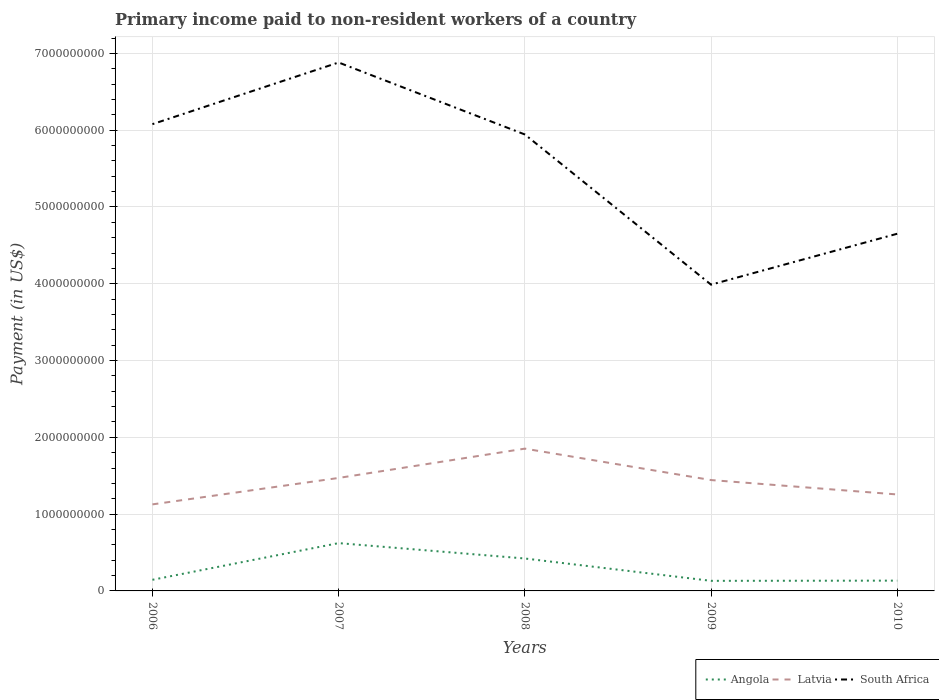How many different coloured lines are there?
Keep it short and to the point. 3. Does the line corresponding to Latvia intersect with the line corresponding to Angola?
Provide a short and direct response. No. Is the number of lines equal to the number of legend labels?
Ensure brevity in your answer.  Yes. Across all years, what is the maximum amount paid to workers in Latvia?
Make the answer very short. 1.13e+09. In which year was the amount paid to workers in Latvia maximum?
Give a very brief answer. 2006. What is the total amount paid to workers in Angola in the graph?
Make the answer very short. -4.78e+08. What is the difference between the highest and the second highest amount paid to workers in South Africa?
Keep it short and to the point. 2.89e+09. What is the difference between the highest and the lowest amount paid to workers in South Africa?
Make the answer very short. 3. Is the amount paid to workers in Angola strictly greater than the amount paid to workers in Latvia over the years?
Offer a terse response. Yes. How many lines are there?
Make the answer very short. 3. How many years are there in the graph?
Provide a succinct answer. 5. What is the difference between two consecutive major ticks on the Y-axis?
Ensure brevity in your answer.  1.00e+09. Does the graph contain grids?
Make the answer very short. Yes. Where does the legend appear in the graph?
Make the answer very short. Bottom right. What is the title of the graph?
Give a very brief answer. Primary income paid to non-resident workers of a country. What is the label or title of the Y-axis?
Make the answer very short. Payment (in US$). What is the Payment (in US$) in Angola in 2006?
Provide a succinct answer. 1.45e+08. What is the Payment (in US$) of Latvia in 2006?
Offer a terse response. 1.13e+09. What is the Payment (in US$) of South Africa in 2006?
Give a very brief answer. 6.08e+09. What is the Payment (in US$) in Angola in 2007?
Offer a terse response. 6.23e+08. What is the Payment (in US$) of Latvia in 2007?
Keep it short and to the point. 1.47e+09. What is the Payment (in US$) in South Africa in 2007?
Give a very brief answer. 6.88e+09. What is the Payment (in US$) of Angola in 2008?
Provide a succinct answer. 4.22e+08. What is the Payment (in US$) of Latvia in 2008?
Keep it short and to the point. 1.85e+09. What is the Payment (in US$) of South Africa in 2008?
Offer a very short reply. 5.94e+09. What is the Payment (in US$) in Angola in 2009?
Keep it short and to the point. 1.31e+08. What is the Payment (in US$) of Latvia in 2009?
Make the answer very short. 1.44e+09. What is the Payment (in US$) in South Africa in 2009?
Your answer should be very brief. 3.99e+09. What is the Payment (in US$) in Angola in 2010?
Provide a short and direct response. 1.34e+08. What is the Payment (in US$) in Latvia in 2010?
Give a very brief answer. 1.26e+09. What is the Payment (in US$) in South Africa in 2010?
Your answer should be compact. 4.65e+09. Across all years, what is the maximum Payment (in US$) of Angola?
Provide a succinct answer. 6.23e+08. Across all years, what is the maximum Payment (in US$) in Latvia?
Provide a succinct answer. 1.85e+09. Across all years, what is the maximum Payment (in US$) in South Africa?
Provide a succinct answer. 6.88e+09. Across all years, what is the minimum Payment (in US$) in Angola?
Keep it short and to the point. 1.31e+08. Across all years, what is the minimum Payment (in US$) of Latvia?
Offer a very short reply. 1.13e+09. Across all years, what is the minimum Payment (in US$) of South Africa?
Your answer should be compact. 3.99e+09. What is the total Payment (in US$) of Angola in the graph?
Keep it short and to the point. 1.46e+09. What is the total Payment (in US$) in Latvia in the graph?
Ensure brevity in your answer.  7.15e+09. What is the total Payment (in US$) of South Africa in the graph?
Offer a very short reply. 2.75e+1. What is the difference between the Payment (in US$) in Angola in 2006 and that in 2007?
Your answer should be very brief. -4.78e+08. What is the difference between the Payment (in US$) of Latvia in 2006 and that in 2007?
Offer a terse response. -3.44e+08. What is the difference between the Payment (in US$) of South Africa in 2006 and that in 2007?
Make the answer very short. -8.03e+08. What is the difference between the Payment (in US$) in Angola in 2006 and that in 2008?
Ensure brevity in your answer.  -2.77e+08. What is the difference between the Payment (in US$) in Latvia in 2006 and that in 2008?
Offer a terse response. -7.26e+08. What is the difference between the Payment (in US$) of South Africa in 2006 and that in 2008?
Make the answer very short. 1.34e+08. What is the difference between the Payment (in US$) in Angola in 2006 and that in 2009?
Provide a succinct answer. 1.37e+07. What is the difference between the Payment (in US$) in Latvia in 2006 and that in 2009?
Offer a terse response. -3.17e+08. What is the difference between the Payment (in US$) in South Africa in 2006 and that in 2009?
Offer a very short reply. 2.09e+09. What is the difference between the Payment (in US$) in Angola in 2006 and that in 2010?
Your response must be concise. 1.10e+07. What is the difference between the Payment (in US$) in Latvia in 2006 and that in 2010?
Ensure brevity in your answer.  -1.29e+08. What is the difference between the Payment (in US$) of South Africa in 2006 and that in 2010?
Provide a succinct answer. 1.43e+09. What is the difference between the Payment (in US$) of Angola in 2007 and that in 2008?
Offer a terse response. 2.00e+08. What is the difference between the Payment (in US$) of Latvia in 2007 and that in 2008?
Provide a succinct answer. -3.82e+08. What is the difference between the Payment (in US$) in South Africa in 2007 and that in 2008?
Offer a terse response. 9.37e+08. What is the difference between the Payment (in US$) of Angola in 2007 and that in 2009?
Ensure brevity in your answer.  4.91e+08. What is the difference between the Payment (in US$) in Latvia in 2007 and that in 2009?
Give a very brief answer. 2.75e+07. What is the difference between the Payment (in US$) in South Africa in 2007 and that in 2009?
Ensure brevity in your answer.  2.89e+09. What is the difference between the Payment (in US$) of Angola in 2007 and that in 2010?
Offer a terse response. 4.89e+08. What is the difference between the Payment (in US$) in Latvia in 2007 and that in 2010?
Give a very brief answer. 2.15e+08. What is the difference between the Payment (in US$) of South Africa in 2007 and that in 2010?
Give a very brief answer. 2.23e+09. What is the difference between the Payment (in US$) in Angola in 2008 and that in 2009?
Ensure brevity in your answer.  2.91e+08. What is the difference between the Payment (in US$) in Latvia in 2008 and that in 2009?
Provide a short and direct response. 4.09e+08. What is the difference between the Payment (in US$) in South Africa in 2008 and that in 2009?
Your answer should be compact. 1.96e+09. What is the difference between the Payment (in US$) in Angola in 2008 and that in 2010?
Keep it short and to the point. 2.88e+08. What is the difference between the Payment (in US$) in Latvia in 2008 and that in 2010?
Ensure brevity in your answer.  5.97e+08. What is the difference between the Payment (in US$) in South Africa in 2008 and that in 2010?
Offer a very short reply. 1.29e+09. What is the difference between the Payment (in US$) in Angola in 2009 and that in 2010?
Your answer should be compact. -2.70e+06. What is the difference between the Payment (in US$) of Latvia in 2009 and that in 2010?
Your response must be concise. 1.88e+08. What is the difference between the Payment (in US$) of South Africa in 2009 and that in 2010?
Provide a succinct answer. -6.63e+08. What is the difference between the Payment (in US$) in Angola in 2006 and the Payment (in US$) in Latvia in 2007?
Your answer should be very brief. -1.33e+09. What is the difference between the Payment (in US$) in Angola in 2006 and the Payment (in US$) in South Africa in 2007?
Offer a terse response. -6.74e+09. What is the difference between the Payment (in US$) of Latvia in 2006 and the Payment (in US$) of South Africa in 2007?
Offer a very short reply. -5.75e+09. What is the difference between the Payment (in US$) in Angola in 2006 and the Payment (in US$) in Latvia in 2008?
Give a very brief answer. -1.71e+09. What is the difference between the Payment (in US$) of Angola in 2006 and the Payment (in US$) of South Africa in 2008?
Your answer should be very brief. -5.80e+09. What is the difference between the Payment (in US$) in Latvia in 2006 and the Payment (in US$) in South Africa in 2008?
Offer a very short reply. -4.82e+09. What is the difference between the Payment (in US$) in Angola in 2006 and the Payment (in US$) in Latvia in 2009?
Offer a very short reply. -1.30e+09. What is the difference between the Payment (in US$) of Angola in 2006 and the Payment (in US$) of South Africa in 2009?
Your answer should be compact. -3.84e+09. What is the difference between the Payment (in US$) in Latvia in 2006 and the Payment (in US$) in South Africa in 2009?
Offer a very short reply. -2.86e+09. What is the difference between the Payment (in US$) in Angola in 2006 and the Payment (in US$) in Latvia in 2010?
Give a very brief answer. -1.11e+09. What is the difference between the Payment (in US$) in Angola in 2006 and the Payment (in US$) in South Africa in 2010?
Ensure brevity in your answer.  -4.51e+09. What is the difference between the Payment (in US$) in Latvia in 2006 and the Payment (in US$) in South Africa in 2010?
Your answer should be compact. -3.52e+09. What is the difference between the Payment (in US$) of Angola in 2007 and the Payment (in US$) of Latvia in 2008?
Keep it short and to the point. -1.23e+09. What is the difference between the Payment (in US$) in Angola in 2007 and the Payment (in US$) in South Africa in 2008?
Offer a very short reply. -5.32e+09. What is the difference between the Payment (in US$) of Latvia in 2007 and the Payment (in US$) of South Africa in 2008?
Offer a very short reply. -4.47e+09. What is the difference between the Payment (in US$) in Angola in 2007 and the Payment (in US$) in Latvia in 2009?
Your answer should be very brief. -8.21e+08. What is the difference between the Payment (in US$) in Angola in 2007 and the Payment (in US$) in South Africa in 2009?
Keep it short and to the point. -3.37e+09. What is the difference between the Payment (in US$) of Latvia in 2007 and the Payment (in US$) of South Africa in 2009?
Provide a short and direct response. -2.52e+09. What is the difference between the Payment (in US$) of Angola in 2007 and the Payment (in US$) of Latvia in 2010?
Give a very brief answer. -6.34e+08. What is the difference between the Payment (in US$) of Angola in 2007 and the Payment (in US$) of South Africa in 2010?
Offer a terse response. -4.03e+09. What is the difference between the Payment (in US$) of Latvia in 2007 and the Payment (in US$) of South Africa in 2010?
Your answer should be compact. -3.18e+09. What is the difference between the Payment (in US$) of Angola in 2008 and the Payment (in US$) of Latvia in 2009?
Your answer should be compact. -1.02e+09. What is the difference between the Payment (in US$) in Angola in 2008 and the Payment (in US$) in South Africa in 2009?
Make the answer very short. -3.57e+09. What is the difference between the Payment (in US$) in Latvia in 2008 and the Payment (in US$) in South Africa in 2009?
Your answer should be very brief. -2.14e+09. What is the difference between the Payment (in US$) in Angola in 2008 and the Payment (in US$) in Latvia in 2010?
Give a very brief answer. -8.34e+08. What is the difference between the Payment (in US$) of Angola in 2008 and the Payment (in US$) of South Africa in 2010?
Keep it short and to the point. -4.23e+09. What is the difference between the Payment (in US$) of Latvia in 2008 and the Payment (in US$) of South Africa in 2010?
Offer a terse response. -2.80e+09. What is the difference between the Payment (in US$) in Angola in 2009 and the Payment (in US$) in Latvia in 2010?
Your answer should be compact. -1.12e+09. What is the difference between the Payment (in US$) in Angola in 2009 and the Payment (in US$) in South Africa in 2010?
Offer a very short reply. -4.52e+09. What is the difference between the Payment (in US$) in Latvia in 2009 and the Payment (in US$) in South Africa in 2010?
Your answer should be compact. -3.21e+09. What is the average Payment (in US$) of Angola per year?
Ensure brevity in your answer.  2.91e+08. What is the average Payment (in US$) of Latvia per year?
Your answer should be very brief. 1.43e+09. What is the average Payment (in US$) of South Africa per year?
Your answer should be very brief. 5.51e+09. In the year 2006, what is the difference between the Payment (in US$) of Angola and Payment (in US$) of Latvia?
Your response must be concise. -9.82e+08. In the year 2006, what is the difference between the Payment (in US$) of Angola and Payment (in US$) of South Africa?
Give a very brief answer. -5.93e+09. In the year 2006, what is the difference between the Payment (in US$) of Latvia and Payment (in US$) of South Africa?
Your answer should be very brief. -4.95e+09. In the year 2007, what is the difference between the Payment (in US$) of Angola and Payment (in US$) of Latvia?
Provide a succinct answer. -8.49e+08. In the year 2007, what is the difference between the Payment (in US$) of Angola and Payment (in US$) of South Africa?
Make the answer very short. -6.26e+09. In the year 2007, what is the difference between the Payment (in US$) in Latvia and Payment (in US$) in South Africa?
Keep it short and to the point. -5.41e+09. In the year 2008, what is the difference between the Payment (in US$) in Angola and Payment (in US$) in Latvia?
Your answer should be compact. -1.43e+09. In the year 2008, what is the difference between the Payment (in US$) of Angola and Payment (in US$) of South Africa?
Give a very brief answer. -5.52e+09. In the year 2008, what is the difference between the Payment (in US$) in Latvia and Payment (in US$) in South Africa?
Your answer should be very brief. -4.09e+09. In the year 2009, what is the difference between the Payment (in US$) in Angola and Payment (in US$) in Latvia?
Provide a succinct answer. -1.31e+09. In the year 2009, what is the difference between the Payment (in US$) in Angola and Payment (in US$) in South Africa?
Provide a succinct answer. -3.86e+09. In the year 2009, what is the difference between the Payment (in US$) in Latvia and Payment (in US$) in South Africa?
Your response must be concise. -2.54e+09. In the year 2010, what is the difference between the Payment (in US$) in Angola and Payment (in US$) in Latvia?
Make the answer very short. -1.12e+09. In the year 2010, what is the difference between the Payment (in US$) of Angola and Payment (in US$) of South Africa?
Your answer should be compact. -4.52e+09. In the year 2010, what is the difference between the Payment (in US$) in Latvia and Payment (in US$) in South Africa?
Your answer should be very brief. -3.40e+09. What is the ratio of the Payment (in US$) of Angola in 2006 to that in 2007?
Ensure brevity in your answer.  0.23. What is the ratio of the Payment (in US$) of Latvia in 2006 to that in 2007?
Your answer should be very brief. 0.77. What is the ratio of the Payment (in US$) of South Africa in 2006 to that in 2007?
Keep it short and to the point. 0.88. What is the ratio of the Payment (in US$) in Angola in 2006 to that in 2008?
Provide a succinct answer. 0.34. What is the ratio of the Payment (in US$) in Latvia in 2006 to that in 2008?
Provide a short and direct response. 0.61. What is the ratio of the Payment (in US$) in South Africa in 2006 to that in 2008?
Provide a short and direct response. 1.02. What is the ratio of the Payment (in US$) in Angola in 2006 to that in 2009?
Make the answer very short. 1.1. What is the ratio of the Payment (in US$) of Latvia in 2006 to that in 2009?
Your answer should be very brief. 0.78. What is the ratio of the Payment (in US$) in South Africa in 2006 to that in 2009?
Your response must be concise. 1.52. What is the ratio of the Payment (in US$) of Angola in 2006 to that in 2010?
Offer a very short reply. 1.08. What is the ratio of the Payment (in US$) in Latvia in 2006 to that in 2010?
Provide a succinct answer. 0.9. What is the ratio of the Payment (in US$) of South Africa in 2006 to that in 2010?
Make the answer very short. 1.31. What is the ratio of the Payment (in US$) of Angola in 2007 to that in 2008?
Make the answer very short. 1.47. What is the ratio of the Payment (in US$) of Latvia in 2007 to that in 2008?
Keep it short and to the point. 0.79. What is the ratio of the Payment (in US$) in South Africa in 2007 to that in 2008?
Offer a very short reply. 1.16. What is the ratio of the Payment (in US$) of Angola in 2007 to that in 2009?
Provide a short and direct response. 4.74. What is the ratio of the Payment (in US$) in South Africa in 2007 to that in 2009?
Make the answer very short. 1.73. What is the ratio of the Payment (in US$) of Angola in 2007 to that in 2010?
Make the answer very short. 4.64. What is the ratio of the Payment (in US$) of Latvia in 2007 to that in 2010?
Keep it short and to the point. 1.17. What is the ratio of the Payment (in US$) of South Africa in 2007 to that in 2010?
Provide a short and direct response. 1.48. What is the ratio of the Payment (in US$) of Angola in 2008 to that in 2009?
Give a very brief answer. 3.22. What is the ratio of the Payment (in US$) of Latvia in 2008 to that in 2009?
Give a very brief answer. 1.28. What is the ratio of the Payment (in US$) in South Africa in 2008 to that in 2009?
Give a very brief answer. 1.49. What is the ratio of the Payment (in US$) of Angola in 2008 to that in 2010?
Provide a short and direct response. 3.15. What is the ratio of the Payment (in US$) of Latvia in 2008 to that in 2010?
Ensure brevity in your answer.  1.48. What is the ratio of the Payment (in US$) in South Africa in 2008 to that in 2010?
Offer a terse response. 1.28. What is the ratio of the Payment (in US$) of Angola in 2009 to that in 2010?
Your answer should be very brief. 0.98. What is the ratio of the Payment (in US$) in Latvia in 2009 to that in 2010?
Offer a very short reply. 1.15. What is the ratio of the Payment (in US$) in South Africa in 2009 to that in 2010?
Your response must be concise. 0.86. What is the difference between the highest and the second highest Payment (in US$) in Angola?
Give a very brief answer. 2.00e+08. What is the difference between the highest and the second highest Payment (in US$) of Latvia?
Your answer should be compact. 3.82e+08. What is the difference between the highest and the second highest Payment (in US$) in South Africa?
Offer a terse response. 8.03e+08. What is the difference between the highest and the lowest Payment (in US$) of Angola?
Offer a very short reply. 4.91e+08. What is the difference between the highest and the lowest Payment (in US$) in Latvia?
Give a very brief answer. 7.26e+08. What is the difference between the highest and the lowest Payment (in US$) of South Africa?
Provide a short and direct response. 2.89e+09. 